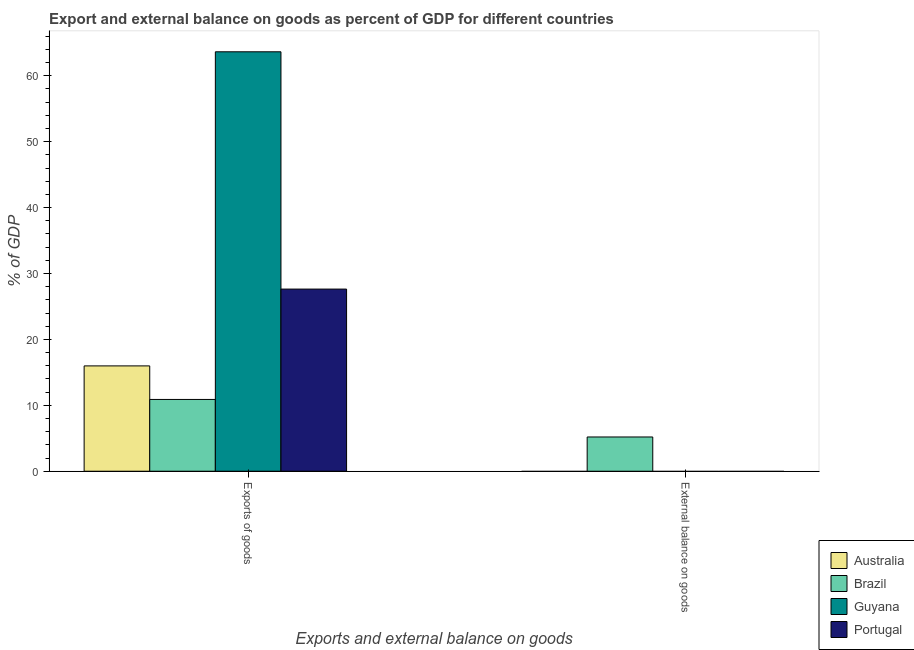How many bars are there on the 2nd tick from the right?
Give a very brief answer. 4. What is the label of the 1st group of bars from the left?
Offer a very short reply. Exports of goods. Across all countries, what is the maximum export of goods as percentage of gdp?
Give a very brief answer. 63.63. Across all countries, what is the minimum export of goods as percentage of gdp?
Your response must be concise. 10.89. In which country was the external balance on goods as percentage of gdp maximum?
Keep it short and to the point. Brazil. What is the total export of goods as percentage of gdp in the graph?
Your answer should be very brief. 118.13. What is the difference between the export of goods as percentage of gdp in Australia and that in Guyana?
Ensure brevity in your answer.  -47.65. What is the difference between the external balance on goods as percentage of gdp in Guyana and the export of goods as percentage of gdp in Australia?
Provide a short and direct response. -15.98. What is the average export of goods as percentage of gdp per country?
Make the answer very short. 29.53. What is the difference between the export of goods as percentage of gdp and external balance on goods as percentage of gdp in Brazil?
Your answer should be very brief. 5.69. What is the ratio of the export of goods as percentage of gdp in Guyana to that in Australia?
Provide a succinct answer. 3.98. Is the export of goods as percentage of gdp in Australia less than that in Guyana?
Provide a succinct answer. Yes. In how many countries, is the export of goods as percentage of gdp greater than the average export of goods as percentage of gdp taken over all countries?
Keep it short and to the point. 1. How many countries are there in the graph?
Give a very brief answer. 4. What is the difference between two consecutive major ticks on the Y-axis?
Your answer should be compact. 10. Does the graph contain any zero values?
Your answer should be very brief. Yes. Where does the legend appear in the graph?
Offer a terse response. Bottom right. How are the legend labels stacked?
Give a very brief answer. Vertical. What is the title of the graph?
Offer a very short reply. Export and external balance on goods as percent of GDP for different countries. Does "Singapore" appear as one of the legend labels in the graph?
Make the answer very short. No. What is the label or title of the X-axis?
Your answer should be compact. Exports and external balance on goods. What is the label or title of the Y-axis?
Ensure brevity in your answer.  % of GDP. What is the % of GDP in Australia in Exports of goods?
Your answer should be very brief. 15.98. What is the % of GDP in Brazil in Exports of goods?
Keep it short and to the point. 10.89. What is the % of GDP of Guyana in Exports of goods?
Provide a succinct answer. 63.63. What is the % of GDP of Portugal in Exports of goods?
Provide a short and direct response. 27.63. What is the % of GDP of Brazil in External balance on goods?
Make the answer very short. 5.2. What is the % of GDP of Guyana in External balance on goods?
Your answer should be compact. 0. What is the % of GDP of Portugal in External balance on goods?
Ensure brevity in your answer.  0. Across all Exports and external balance on goods, what is the maximum % of GDP of Australia?
Make the answer very short. 15.98. Across all Exports and external balance on goods, what is the maximum % of GDP in Brazil?
Your answer should be very brief. 10.89. Across all Exports and external balance on goods, what is the maximum % of GDP of Guyana?
Provide a succinct answer. 63.63. Across all Exports and external balance on goods, what is the maximum % of GDP of Portugal?
Offer a very short reply. 27.63. Across all Exports and external balance on goods, what is the minimum % of GDP of Australia?
Make the answer very short. 0. Across all Exports and external balance on goods, what is the minimum % of GDP in Brazil?
Ensure brevity in your answer.  5.2. Across all Exports and external balance on goods, what is the minimum % of GDP in Guyana?
Your response must be concise. 0. What is the total % of GDP of Australia in the graph?
Provide a short and direct response. 15.98. What is the total % of GDP of Brazil in the graph?
Your response must be concise. 16.08. What is the total % of GDP of Guyana in the graph?
Your answer should be very brief. 63.63. What is the total % of GDP of Portugal in the graph?
Ensure brevity in your answer.  27.63. What is the difference between the % of GDP in Brazil in Exports of goods and that in External balance on goods?
Your response must be concise. 5.69. What is the difference between the % of GDP of Australia in Exports of goods and the % of GDP of Brazil in External balance on goods?
Offer a very short reply. 10.78. What is the average % of GDP of Australia per Exports and external balance on goods?
Your answer should be compact. 7.99. What is the average % of GDP in Brazil per Exports and external balance on goods?
Offer a terse response. 8.04. What is the average % of GDP of Guyana per Exports and external balance on goods?
Provide a succinct answer. 31.81. What is the average % of GDP in Portugal per Exports and external balance on goods?
Offer a terse response. 13.82. What is the difference between the % of GDP in Australia and % of GDP in Brazil in Exports of goods?
Your answer should be very brief. 5.09. What is the difference between the % of GDP of Australia and % of GDP of Guyana in Exports of goods?
Ensure brevity in your answer.  -47.65. What is the difference between the % of GDP of Australia and % of GDP of Portugal in Exports of goods?
Your response must be concise. -11.65. What is the difference between the % of GDP in Brazil and % of GDP in Guyana in Exports of goods?
Provide a short and direct response. -52.74. What is the difference between the % of GDP in Brazil and % of GDP in Portugal in Exports of goods?
Provide a short and direct response. -16.74. What is the difference between the % of GDP in Guyana and % of GDP in Portugal in Exports of goods?
Your answer should be very brief. 36. What is the ratio of the % of GDP in Brazil in Exports of goods to that in External balance on goods?
Provide a succinct answer. 2.1. What is the difference between the highest and the second highest % of GDP in Brazil?
Ensure brevity in your answer.  5.69. What is the difference between the highest and the lowest % of GDP of Australia?
Ensure brevity in your answer.  15.98. What is the difference between the highest and the lowest % of GDP of Brazil?
Offer a very short reply. 5.69. What is the difference between the highest and the lowest % of GDP in Guyana?
Your answer should be compact. 63.63. What is the difference between the highest and the lowest % of GDP of Portugal?
Your answer should be compact. 27.63. 